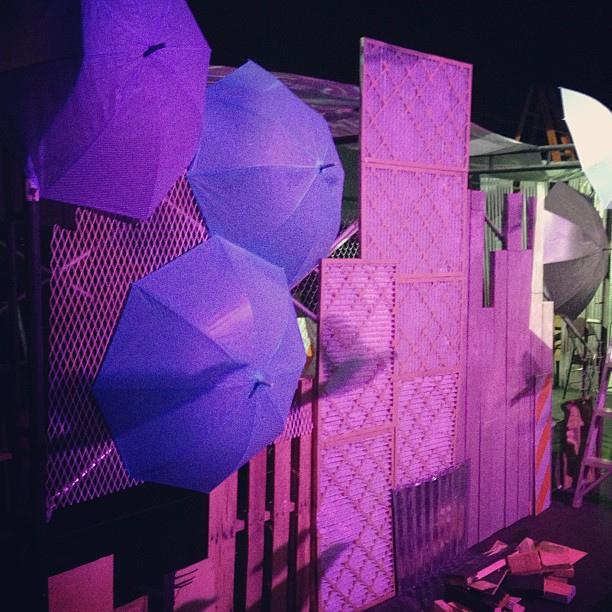Where are the purple screens?
Write a very short answer. Hanging. How many purple umbrellas are there?
Give a very brief answer. 3. Is this considered artwork?
Keep it brief. Yes. 